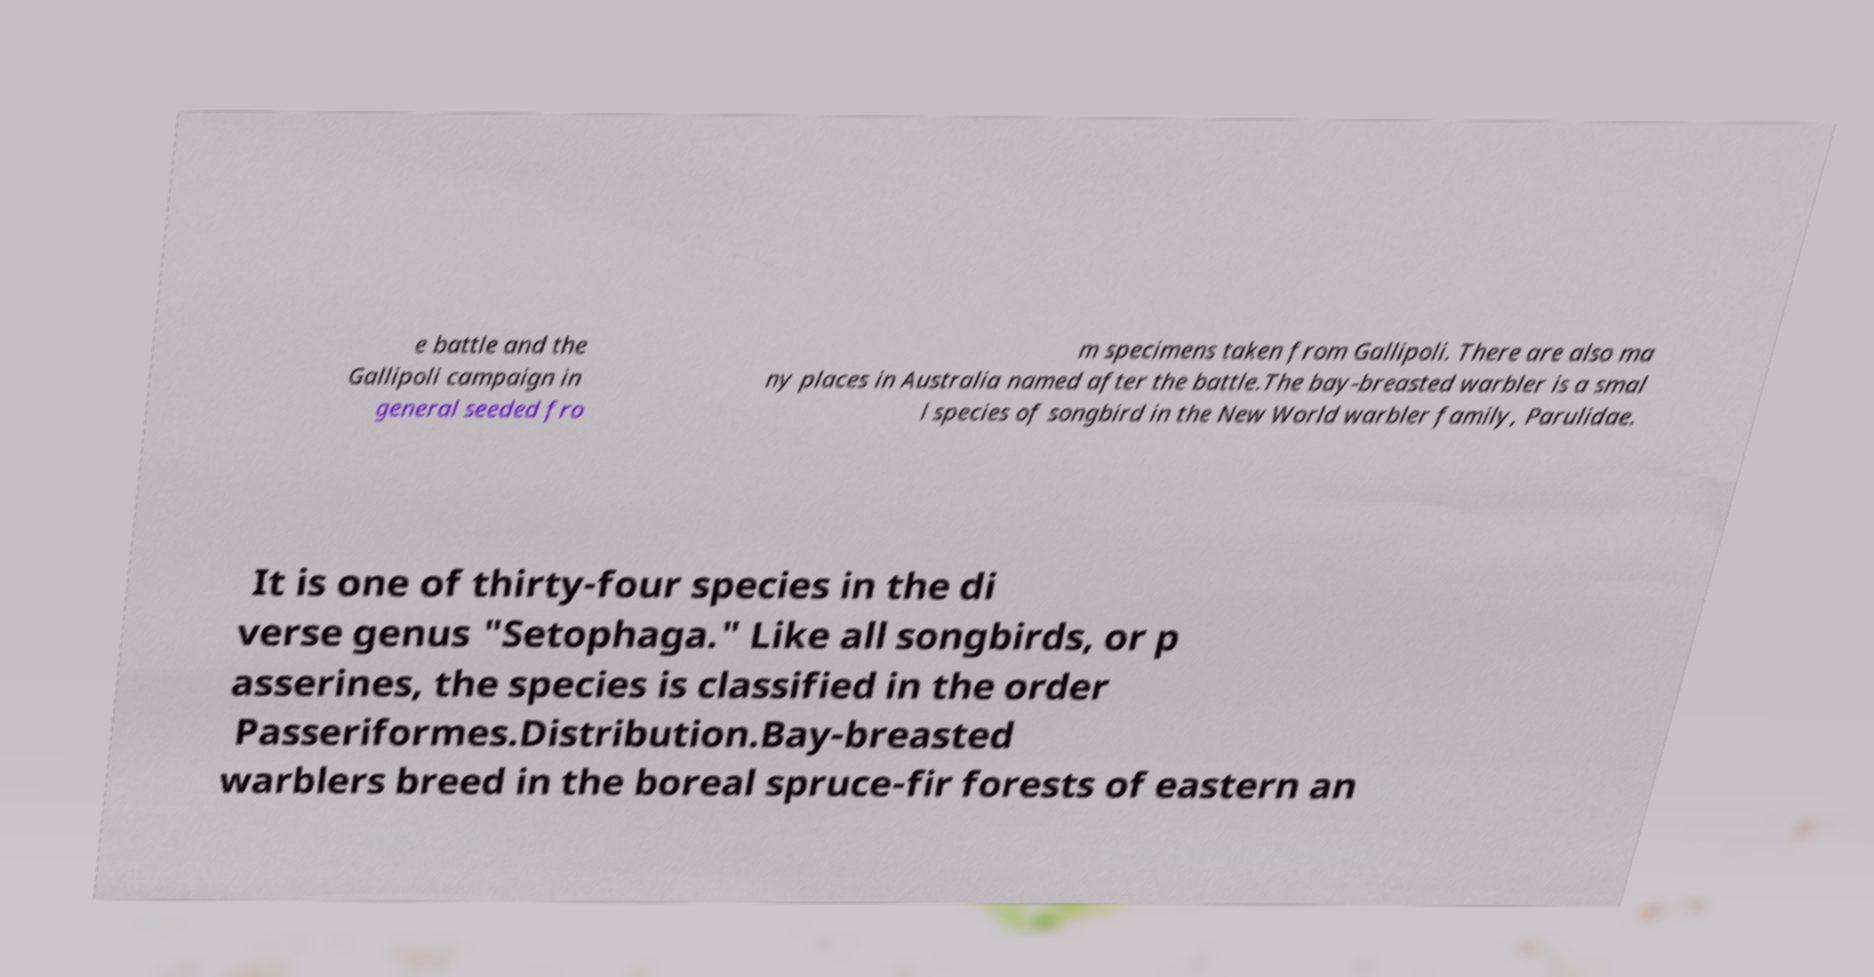Please read and relay the text visible in this image. What does it say? e battle and the Gallipoli campaign in general seeded fro m specimens taken from Gallipoli. There are also ma ny places in Australia named after the battle.The bay-breasted warbler is a smal l species of songbird in the New World warbler family, Parulidae. It is one of thirty-four species in the di verse genus "Setophaga." Like all songbirds, or p asserines, the species is classified in the order Passeriformes.Distribution.Bay-breasted warblers breed in the boreal spruce-fir forests of eastern an 